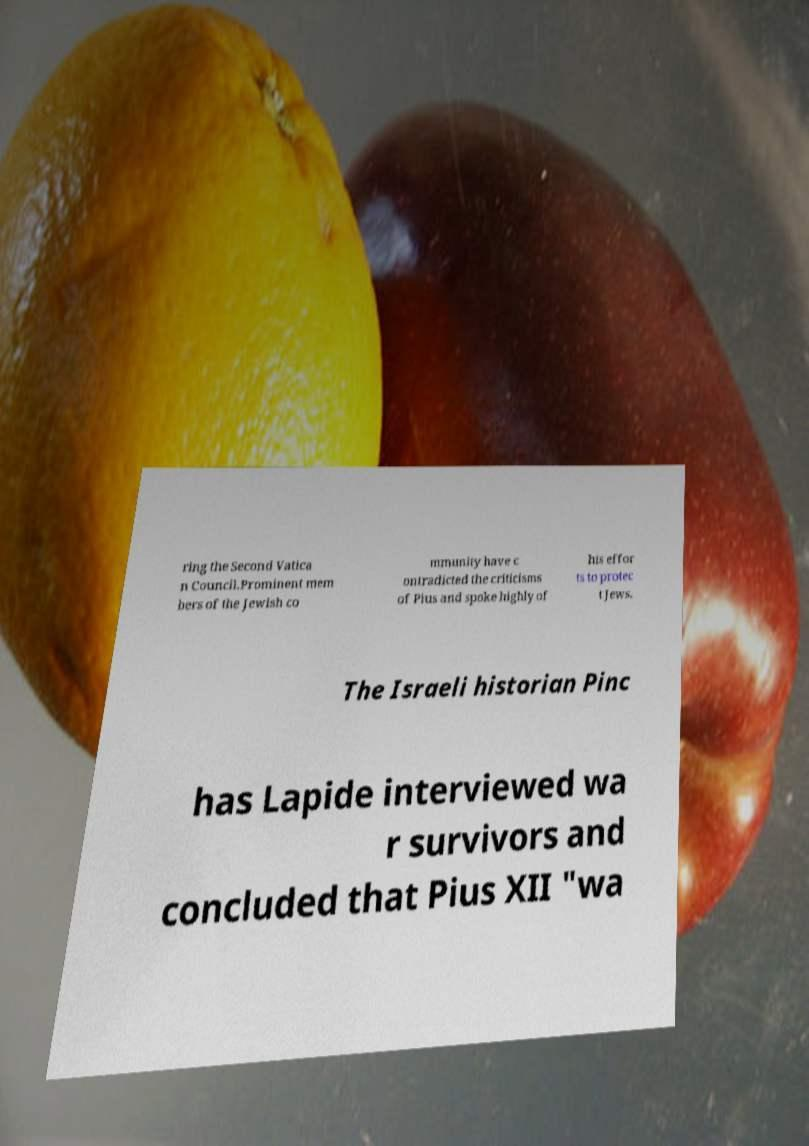Could you assist in decoding the text presented in this image and type it out clearly? ring the Second Vatica n Council.Prominent mem bers of the Jewish co mmunity have c ontradicted the criticisms of Pius and spoke highly of his effor ts to protec t Jews. The Israeli historian Pinc has Lapide interviewed wa r survivors and concluded that Pius XII "wa 